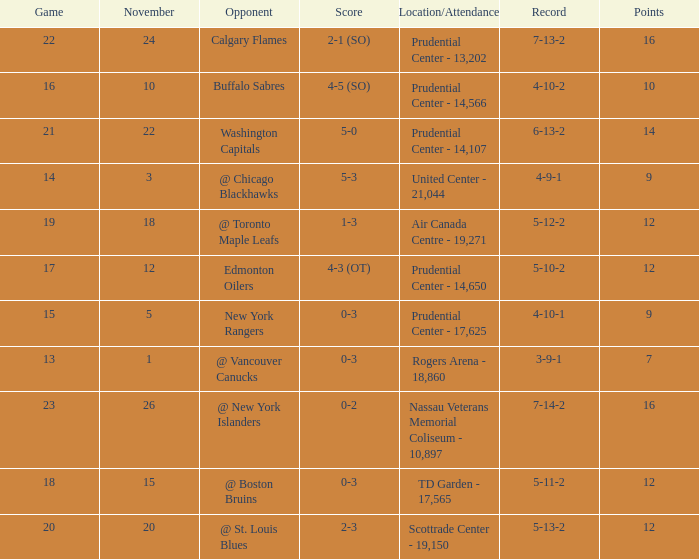What is the maximum number of points? 16.0. 